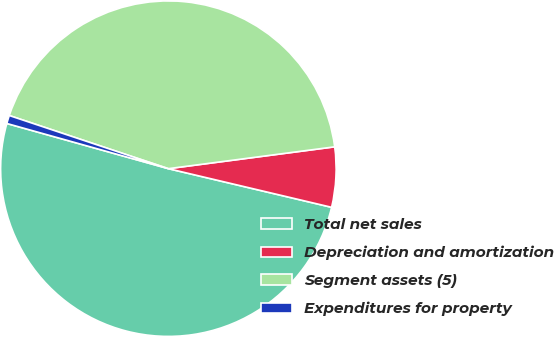<chart> <loc_0><loc_0><loc_500><loc_500><pie_chart><fcel>Total net sales<fcel>Depreciation and amortization<fcel>Segment assets (5)<fcel>Expenditures for property<nl><fcel>50.64%<fcel>5.78%<fcel>42.79%<fcel>0.79%<nl></chart> 